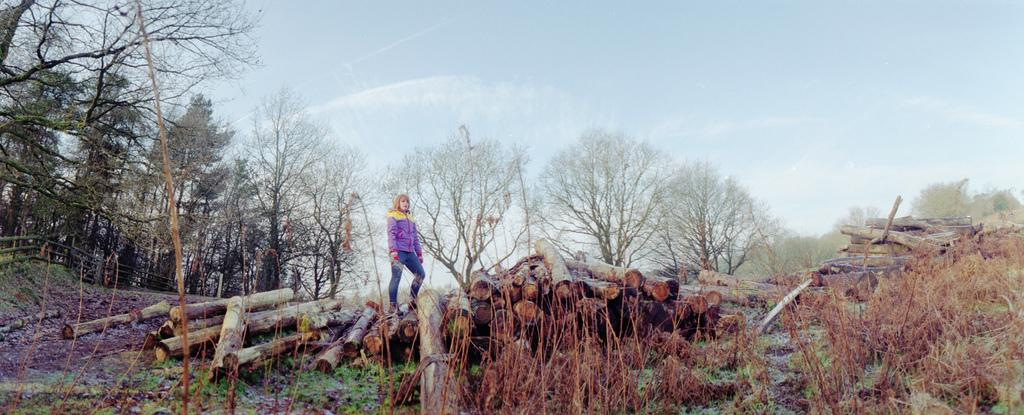What is the primary subject of the image? There are many logs in the image. Can you describe the woman in the image? A woman is standing in the background of the image. What else can be seen in the background of the image? There are trees in the background of the image. How would you describe the weather in the image? The sky is cloudy in the background of the image. What type of snakes are slithering around the logs in the image? There are no snakes present in the image; it only features logs, a woman, trees, and a cloudy sky. 